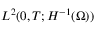<formula> <loc_0><loc_0><loc_500><loc_500>L ^ { 2 } ( 0 , T ; H ^ { - 1 } ( \Omega ) )</formula> 